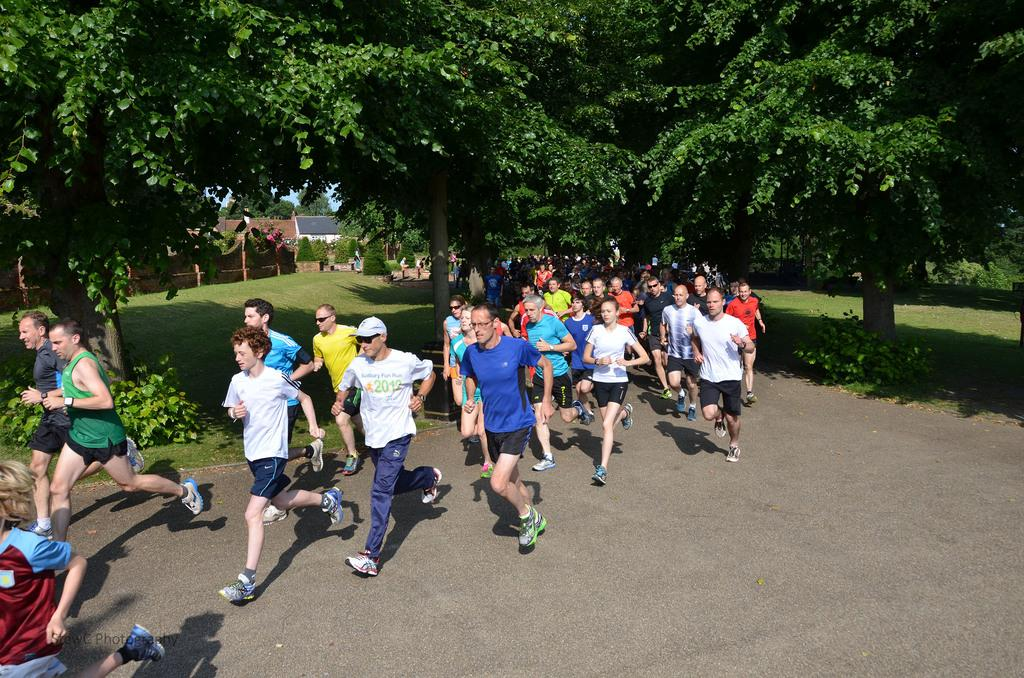What are the people in the image doing? The people in the image are running on the road. What can be seen in the background of the image? There are trees, houses, and green grass visible in the background of the image. What type of plant is the money growing on in the image? There is no plant or money present in the image. 